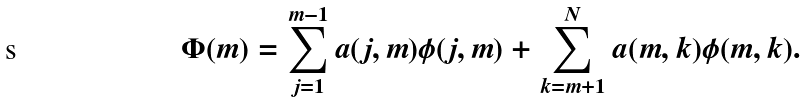Convert formula to latex. <formula><loc_0><loc_0><loc_500><loc_500>\Phi ( m ) = \sum _ { j = 1 } ^ { m - 1 } a ( j , m ) \phi ( j , m ) + \sum _ { k = m + 1 } ^ { N } a ( m , k ) \phi ( m , k ) .</formula> 